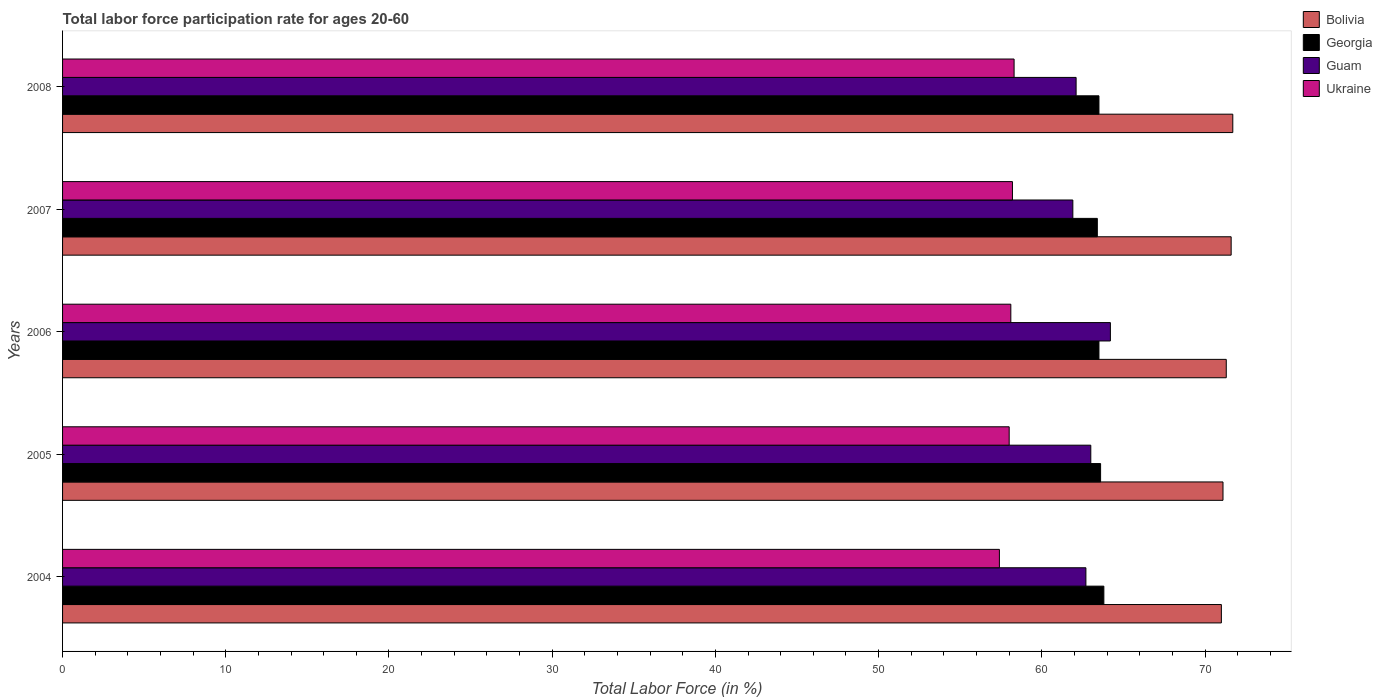How many different coloured bars are there?
Provide a succinct answer. 4. How many groups of bars are there?
Keep it short and to the point. 5. Are the number of bars per tick equal to the number of legend labels?
Offer a terse response. Yes. Are the number of bars on each tick of the Y-axis equal?
Make the answer very short. Yes. How many bars are there on the 4th tick from the top?
Provide a succinct answer. 4. How many bars are there on the 5th tick from the bottom?
Ensure brevity in your answer.  4. In how many cases, is the number of bars for a given year not equal to the number of legend labels?
Provide a succinct answer. 0. What is the labor force participation rate in Guam in 2006?
Make the answer very short. 64.2. Across all years, what is the maximum labor force participation rate in Georgia?
Keep it short and to the point. 63.8. Across all years, what is the minimum labor force participation rate in Georgia?
Make the answer very short. 63.4. What is the total labor force participation rate in Georgia in the graph?
Your answer should be compact. 317.8. What is the difference between the labor force participation rate in Georgia in 2006 and that in 2008?
Your response must be concise. 0. What is the difference between the labor force participation rate in Georgia in 2004 and the labor force participation rate in Ukraine in 2007?
Ensure brevity in your answer.  5.6. What is the average labor force participation rate in Ukraine per year?
Provide a succinct answer. 58. In the year 2006, what is the difference between the labor force participation rate in Bolivia and labor force participation rate in Georgia?
Provide a succinct answer. 7.8. In how many years, is the labor force participation rate in Ukraine greater than 38 %?
Your answer should be compact. 5. What is the ratio of the labor force participation rate in Bolivia in 2006 to that in 2008?
Your answer should be compact. 0.99. Is the labor force participation rate in Bolivia in 2006 less than that in 2007?
Keep it short and to the point. Yes. Is the difference between the labor force participation rate in Bolivia in 2004 and 2008 greater than the difference between the labor force participation rate in Georgia in 2004 and 2008?
Your answer should be very brief. No. What is the difference between the highest and the second highest labor force participation rate in Georgia?
Provide a succinct answer. 0.2. What is the difference between the highest and the lowest labor force participation rate in Georgia?
Ensure brevity in your answer.  0.4. Is the sum of the labor force participation rate in Ukraine in 2004 and 2006 greater than the maximum labor force participation rate in Georgia across all years?
Keep it short and to the point. Yes. What does the 2nd bar from the top in 2004 represents?
Offer a terse response. Guam. What does the 4th bar from the bottom in 2008 represents?
Offer a terse response. Ukraine. Are all the bars in the graph horizontal?
Make the answer very short. Yes. What is the difference between two consecutive major ticks on the X-axis?
Your answer should be compact. 10. Are the values on the major ticks of X-axis written in scientific E-notation?
Keep it short and to the point. No. How many legend labels are there?
Offer a terse response. 4. How are the legend labels stacked?
Your answer should be very brief. Vertical. What is the title of the graph?
Ensure brevity in your answer.  Total labor force participation rate for ages 20-60. What is the label or title of the X-axis?
Provide a short and direct response. Total Labor Force (in %). What is the label or title of the Y-axis?
Make the answer very short. Years. What is the Total Labor Force (in %) of Bolivia in 2004?
Provide a short and direct response. 71. What is the Total Labor Force (in %) in Georgia in 2004?
Your answer should be very brief. 63.8. What is the Total Labor Force (in %) of Guam in 2004?
Provide a short and direct response. 62.7. What is the Total Labor Force (in %) of Ukraine in 2004?
Keep it short and to the point. 57.4. What is the Total Labor Force (in %) of Bolivia in 2005?
Keep it short and to the point. 71.1. What is the Total Labor Force (in %) in Georgia in 2005?
Your answer should be very brief. 63.6. What is the Total Labor Force (in %) in Ukraine in 2005?
Your response must be concise. 58. What is the Total Labor Force (in %) in Bolivia in 2006?
Give a very brief answer. 71.3. What is the Total Labor Force (in %) of Georgia in 2006?
Your answer should be very brief. 63.5. What is the Total Labor Force (in %) in Guam in 2006?
Provide a short and direct response. 64.2. What is the Total Labor Force (in %) in Ukraine in 2006?
Provide a succinct answer. 58.1. What is the Total Labor Force (in %) of Bolivia in 2007?
Keep it short and to the point. 71.6. What is the Total Labor Force (in %) of Georgia in 2007?
Your answer should be very brief. 63.4. What is the Total Labor Force (in %) of Guam in 2007?
Provide a succinct answer. 61.9. What is the Total Labor Force (in %) of Ukraine in 2007?
Make the answer very short. 58.2. What is the Total Labor Force (in %) of Bolivia in 2008?
Ensure brevity in your answer.  71.7. What is the Total Labor Force (in %) of Georgia in 2008?
Give a very brief answer. 63.5. What is the Total Labor Force (in %) of Guam in 2008?
Offer a terse response. 62.1. What is the Total Labor Force (in %) of Ukraine in 2008?
Offer a terse response. 58.3. Across all years, what is the maximum Total Labor Force (in %) in Bolivia?
Your answer should be compact. 71.7. Across all years, what is the maximum Total Labor Force (in %) in Georgia?
Make the answer very short. 63.8. Across all years, what is the maximum Total Labor Force (in %) in Guam?
Offer a terse response. 64.2. Across all years, what is the maximum Total Labor Force (in %) of Ukraine?
Your response must be concise. 58.3. Across all years, what is the minimum Total Labor Force (in %) of Bolivia?
Provide a succinct answer. 71. Across all years, what is the minimum Total Labor Force (in %) of Georgia?
Your response must be concise. 63.4. Across all years, what is the minimum Total Labor Force (in %) of Guam?
Give a very brief answer. 61.9. Across all years, what is the minimum Total Labor Force (in %) of Ukraine?
Give a very brief answer. 57.4. What is the total Total Labor Force (in %) in Bolivia in the graph?
Offer a terse response. 356.7. What is the total Total Labor Force (in %) of Georgia in the graph?
Provide a succinct answer. 317.8. What is the total Total Labor Force (in %) in Guam in the graph?
Provide a short and direct response. 313.9. What is the total Total Labor Force (in %) in Ukraine in the graph?
Offer a terse response. 290. What is the difference between the Total Labor Force (in %) of Georgia in 2004 and that in 2005?
Ensure brevity in your answer.  0.2. What is the difference between the Total Labor Force (in %) in Bolivia in 2004 and that in 2006?
Provide a short and direct response. -0.3. What is the difference between the Total Labor Force (in %) in Guam in 2004 and that in 2006?
Provide a succinct answer. -1.5. What is the difference between the Total Labor Force (in %) of Ukraine in 2004 and that in 2006?
Make the answer very short. -0.7. What is the difference between the Total Labor Force (in %) of Bolivia in 2004 and that in 2007?
Your answer should be very brief. -0.6. What is the difference between the Total Labor Force (in %) in Bolivia in 2004 and that in 2008?
Your answer should be compact. -0.7. What is the difference between the Total Labor Force (in %) in Georgia in 2004 and that in 2008?
Ensure brevity in your answer.  0.3. What is the difference between the Total Labor Force (in %) of Guam in 2004 and that in 2008?
Offer a very short reply. 0.6. What is the difference between the Total Labor Force (in %) of Ukraine in 2004 and that in 2008?
Offer a very short reply. -0.9. What is the difference between the Total Labor Force (in %) of Bolivia in 2005 and that in 2006?
Provide a succinct answer. -0.2. What is the difference between the Total Labor Force (in %) in Bolivia in 2005 and that in 2007?
Provide a succinct answer. -0.5. What is the difference between the Total Labor Force (in %) of Georgia in 2005 and that in 2007?
Make the answer very short. 0.2. What is the difference between the Total Labor Force (in %) in Guam in 2005 and that in 2008?
Provide a short and direct response. 0.9. What is the difference between the Total Labor Force (in %) in Georgia in 2006 and that in 2007?
Offer a terse response. 0.1. What is the difference between the Total Labor Force (in %) in Ukraine in 2006 and that in 2007?
Keep it short and to the point. -0.1. What is the difference between the Total Labor Force (in %) in Georgia in 2006 and that in 2008?
Offer a very short reply. 0. What is the difference between the Total Labor Force (in %) in Guam in 2006 and that in 2008?
Your answer should be compact. 2.1. What is the difference between the Total Labor Force (in %) in Bolivia in 2007 and that in 2008?
Your response must be concise. -0.1. What is the difference between the Total Labor Force (in %) of Ukraine in 2007 and that in 2008?
Ensure brevity in your answer.  -0.1. What is the difference between the Total Labor Force (in %) of Bolivia in 2004 and the Total Labor Force (in %) of Georgia in 2005?
Offer a very short reply. 7.4. What is the difference between the Total Labor Force (in %) of Georgia in 2004 and the Total Labor Force (in %) of Guam in 2005?
Give a very brief answer. 0.8. What is the difference between the Total Labor Force (in %) of Guam in 2004 and the Total Labor Force (in %) of Ukraine in 2005?
Provide a short and direct response. 4.7. What is the difference between the Total Labor Force (in %) of Georgia in 2004 and the Total Labor Force (in %) of Guam in 2006?
Offer a very short reply. -0.4. What is the difference between the Total Labor Force (in %) of Georgia in 2004 and the Total Labor Force (in %) of Ukraine in 2006?
Make the answer very short. 5.7. What is the difference between the Total Labor Force (in %) of Guam in 2004 and the Total Labor Force (in %) of Ukraine in 2006?
Offer a very short reply. 4.6. What is the difference between the Total Labor Force (in %) of Bolivia in 2004 and the Total Labor Force (in %) of Guam in 2007?
Give a very brief answer. 9.1. What is the difference between the Total Labor Force (in %) of Bolivia in 2004 and the Total Labor Force (in %) of Ukraine in 2007?
Ensure brevity in your answer.  12.8. What is the difference between the Total Labor Force (in %) in Georgia in 2004 and the Total Labor Force (in %) in Guam in 2007?
Offer a terse response. 1.9. What is the difference between the Total Labor Force (in %) in Georgia in 2004 and the Total Labor Force (in %) in Ukraine in 2007?
Your response must be concise. 5.6. What is the difference between the Total Labor Force (in %) in Guam in 2004 and the Total Labor Force (in %) in Ukraine in 2007?
Your answer should be very brief. 4.5. What is the difference between the Total Labor Force (in %) of Bolivia in 2004 and the Total Labor Force (in %) of Georgia in 2008?
Provide a succinct answer. 7.5. What is the difference between the Total Labor Force (in %) of Bolivia in 2004 and the Total Labor Force (in %) of Ukraine in 2008?
Keep it short and to the point. 12.7. What is the difference between the Total Labor Force (in %) of Georgia in 2004 and the Total Labor Force (in %) of Guam in 2008?
Give a very brief answer. 1.7. What is the difference between the Total Labor Force (in %) in Georgia in 2004 and the Total Labor Force (in %) in Ukraine in 2008?
Give a very brief answer. 5.5. What is the difference between the Total Labor Force (in %) of Guam in 2004 and the Total Labor Force (in %) of Ukraine in 2008?
Offer a very short reply. 4.4. What is the difference between the Total Labor Force (in %) in Bolivia in 2005 and the Total Labor Force (in %) in Ukraine in 2006?
Make the answer very short. 13. What is the difference between the Total Labor Force (in %) in Georgia in 2005 and the Total Labor Force (in %) in Ukraine in 2006?
Your answer should be compact. 5.5. What is the difference between the Total Labor Force (in %) in Bolivia in 2005 and the Total Labor Force (in %) in Ukraine in 2007?
Provide a short and direct response. 12.9. What is the difference between the Total Labor Force (in %) in Georgia in 2005 and the Total Labor Force (in %) in Guam in 2007?
Give a very brief answer. 1.7. What is the difference between the Total Labor Force (in %) of Georgia in 2005 and the Total Labor Force (in %) of Ukraine in 2007?
Keep it short and to the point. 5.4. What is the difference between the Total Labor Force (in %) in Bolivia in 2005 and the Total Labor Force (in %) in Georgia in 2008?
Ensure brevity in your answer.  7.6. What is the difference between the Total Labor Force (in %) of Bolivia in 2005 and the Total Labor Force (in %) of Ukraine in 2008?
Give a very brief answer. 12.8. What is the difference between the Total Labor Force (in %) in Georgia in 2005 and the Total Labor Force (in %) in Guam in 2008?
Make the answer very short. 1.5. What is the difference between the Total Labor Force (in %) of Guam in 2006 and the Total Labor Force (in %) of Ukraine in 2007?
Give a very brief answer. 6. What is the difference between the Total Labor Force (in %) in Bolivia in 2006 and the Total Labor Force (in %) in Georgia in 2008?
Offer a terse response. 7.8. What is the difference between the Total Labor Force (in %) of Georgia in 2006 and the Total Labor Force (in %) of Guam in 2008?
Your answer should be compact. 1.4. What is the difference between the Total Labor Force (in %) of Georgia in 2006 and the Total Labor Force (in %) of Ukraine in 2008?
Your response must be concise. 5.2. What is the difference between the Total Labor Force (in %) in Guam in 2006 and the Total Labor Force (in %) in Ukraine in 2008?
Your answer should be compact. 5.9. What is the difference between the Total Labor Force (in %) in Bolivia in 2007 and the Total Labor Force (in %) in Georgia in 2008?
Ensure brevity in your answer.  8.1. What is the difference between the Total Labor Force (in %) of Bolivia in 2007 and the Total Labor Force (in %) of Ukraine in 2008?
Your answer should be very brief. 13.3. What is the difference between the Total Labor Force (in %) of Georgia in 2007 and the Total Labor Force (in %) of Guam in 2008?
Provide a short and direct response. 1.3. What is the difference between the Total Labor Force (in %) in Georgia in 2007 and the Total Labor Force (in %) in Ukraine in 2008?
Ensure brevity in your answer.  5.1. What is the difference between the Total Labor Force (in %) in Guam in 2007 and the Total Labor Force (in %) in Ukraine in 2008?
Your answer should be very brief. 3.6. What is the average Total Labor Force (in %) of Bolivia per year?
Keep it short and to the point. 71.34. What is the average Total Labor Force (in %) of Georgia per year?
Offer a very short reply. 63.56. What is the average Total Labor Force (in %) in Guam per year?
Make the answer very short. 62.78. In the year 2004, what is the difference between the Total Labor Force (in %) in Bolivia and Total Labor Force (in %) in Georgia?
Keep it short and to the point. 7.2. In the year 2004, what is the difference between the Total Labor Force (in %) of Bolivia and Total Labor Force (in %) of Guam?
Your response must be concise. 8.3. In the year 2004, what is the difference between the Total Labor Force (in %) in Bolivia and Total Labor Force (in %) in Ukraine?
Give a very brief answer. 13.6. In the year 2004, what is the difference between the Total Labor Force (in %) of Georgia and Total Labor Force (in %) of Ukraine?
Give a very brief answer. 6.4. In the year 2004, what is the difference between the Total Labor Force (in %) of Guam and Total Labor Force (in %) of Ukraine?
Offer a very short reply. 5.3. In the year 2005, what is the difference between the Total Labor Force (in %) of Bolivia and Total Labor Force (in %) of Georgia?
Your answer should be very brief. 7.5. In the year 2005, what is the difference between the Total Labor Force (in %) in Bolivia and Total Labor Force (in %) in Guam?
Provide a short and direct response. 8.1. In the year 2005, what is the difference between the Total Labor Force (in %) of Bolivia and Total Labor Force (in %) of Ukraine?
Your response must be concise. 13.1. In the year 2005, what is the difference between the Total Labor Force (in %) in Georgia and Total Labor Force (in %) in Ukraine?
Provide a succinct answer. 5.6. In the year 2005, what is the difference between the Total Labor Force (in %) in Guam and Total Labor Force (in %) in Ukraine?
Ensure brevity in your answer.  5. In the year 2006, what is the difference between the Total Labor Force (in %) in Georgia and Total Labor Force (in %) in Ukraine?
Ensure brevity in your answer.  5.4. In the year 2006, what is the difference between the Total Labor Force (in %) in Guam and Total Labor Force (in %) in Ukraine?
Your answer should be compact. 6.1. In the year 2007, what is the difference between the Total Labor Force (in %) of Bolivia and Total Labor Force (in %) of Georgia?
Keep it short and to the point. 8.2. In the year 2007, what is the difference between the Total Labor Force (in %) in Bolivia and Total Labor Force (in %) in Ukraine?
Give a very brief answer. 13.4. In the year 2007, what is the difference between the Total Labor Force (in %) of Georgia and Total Labor Force (in %) of Guam?
Give a very brief answer. 1.5. In the year 2007, what is the difference between the Total Labor Force (in %) of Georgia and Total Labor Force (in %) of Ukraine?
Offer a very short reply. 5.2. In the year 2008, what is the difference between the Total Labor Force (in %) in Bolivia and Total Labor Force (in %) in Georgia?
Offer a terse response. 8.2. In the year 2008, what is the difference between the Total Labor Force (in %) in Bolivia and Total Labor Force (in %) in Ukraine?
Your answer should be very brief. 13.4. In the year 2008, what is the difference between the Total Labor Force (in %) in Guam and Total Labor Force (in %) in Ukraine?
Your response must be concise. 3.8. What is the ratio of the Total Labor Force (in %) in Bolivia in 2004 to that in 2005?
Give a very brief answer. 1. What is the ratio of the Total Labor Force (in %) of Guam in 2004 to that in 2005?
Your response must be concise. 1. What is the ratio of the Total Labor Force (in %) in Bolivia in 2004 to that in 2006?
Your response must be concise. 1. What is the ratio of the Total Labor Force (in %) of Georgia in 2004 to that in 2006?
Ensure brevity in your answer.  1. What is the ratio of the Total Labor Force (in %) of Guam in 2004 to that in 2006?
Ensure brevity in your answer.  0.98. What is the ratio of the Total Labor Force (in %) in Bolivia in 2004 to that in 2007?
Give a very brief answer. 0.99. What is the ratio of the Total Labor Force (in %) in Guam in 2004 to that in 2007?
Offer a very short reply. 1.01. What is the ratio of the Total Labor Force (in %) of Ukraine in 2004 to that in 2007?
Your answer should be compact. 0.99. What is the ratio of the Total Labor Force (in %) in Bolivia in 2004 to that in 2008?
Provide a short and direct response. 0.99. What is the ratio of the Total Labor Force (in %) of Guam in 2004 to that in 2008?
Your answer should be very brief. 1.01. What is the ratio of the Total Labor Force (in %) in Ukraine in 2004 to that in 2008?
Make the answer very short. 0.98. What is the ratio of the Total Labor Force (in %) of Bolivia in 2005 to that in 2006?
Your answer should be very brief. 1. What is the ratio of the Total Labor Force (in %) in Georgia in 2005 to that in 2006?
Your answer should be very brief. 1. What is the ratio of the Total Labor Force (in %) of Guam in 2005 to that in 2006?
Ensure brevity in your answer.  0.98. What is the ratio of the Total Labor Force (in %) in Georgia in 2005 to that in 2007?
Your response must be concise. 1. What is the ratio of the Total Labor Force (in %) of Guam in 2005 to that in 2007?
Ensure brevity in your answer.  1.02. What is the ratio of the Total Labor Force (in %) of Ukraine in 2005 to that in 2007?
Your answer should be very brief. 1. What is the ratio of the Total Labor Force (in %) in Bolivia in 2005 to that in 2008?
Keep it short and to the point. 0.99. What is the ratio of the Total Labor Force (in %) of Guam in 2005 to that in 2008?
Your answer should be compact. 1.01. What is the ratio of the Total Labor Force (in %) of Bolivia in 2006 to that in 2007?
Make the answer very short. 1. What is the ratio of the Total Labor Force (in %) in Guam in 2006 to that in 2007?
Offer a very short reply. 1.04. What is the ratio of the Total Labor Force (in %) of Ukraine in 2006 to that in 2007?
Keep it short and to the point. 1. What is the ratio of the Total Labor Force (in %) of Bolivia in 2006 to that in 2008?
Provide a short and direct response. 0.99. What is the ratio of the Total Labor Force (in %) of Guam in 2006 to that in 2008?
Ensure brevity in your answer.  1.03. What is the ratio of the Total Labor Force (in %) in Ukraine in 2006 to that in 2008?
Provide a short and direct response. 1. What is the ratio of the Total Labor Force (in %) of Guam in 2007 to that in 2008?
Provide a short and direct response. 1. What is the ratio of the Total Labor Force (in %) in Ukraine in 2007 to that in 2008?
Keep it short and to the point. 1. What is the difference between the highest and the second highest Total Labor Force (in %) of Georgia?
Provide a short and direct response. 0.2. What is the difference between the highest and the second highest Total Labor Force (in %) of Guam?
Provide a succinct answer. 1.2. What is the difference between the highest and the lowest Total Labor Force (in %) of Georgia?
Make the answer very short. 0.4. 